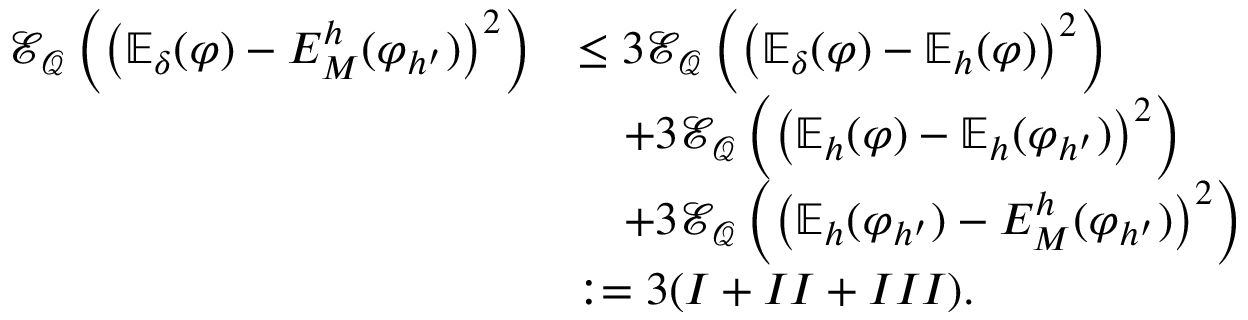Convert formula to latex. <formula><loc_0><loc_0><loc_500><loc_500>\begin{array} { r l } { \mathcal { E } _ { \mathcal { Q } } \left ( \left ( \mathbb { E } _ { \delta } ( \varphi ) - E _ { M } ^ { h } ( \varphi _ { h ^ { \prime } } ) \right ) ^ { 2 } \right ) } & { \leq 3 \mathcal { E } _ { \mathcal { Q } } \left ( \left ( \mathbb { E } _ { \delta } ( \varphi ) - \mathbb { E } _ { h } ( \varphi ) \right ) ^ { 2 } \right ) } \\ & { \quad + 3 \mathcal { E } _ { \mathcal { Q } } \left ( \left ( \mathbb { E } _ { h } ( \varphi ) - \mathbb { E } _ { h } ( \varphi _ { h ^ { \prime } } ) \right ) ^ { 2 } \right ) } \\ & { \quad + 3 \mathcal { E } _ { \mathcal { Q } } \left ( \left ( \mathbb { E } _ { h } ( \varphi _ { h ^ { \prime } } ) - E _ { M } ^ { h } ( \varphi _ { h ^ { \prime } } ) \right ) ^ { 2 } \right ) } \\ & { \colon = 3 ( I + I I + I I I ) . } \end{array}</formula> 